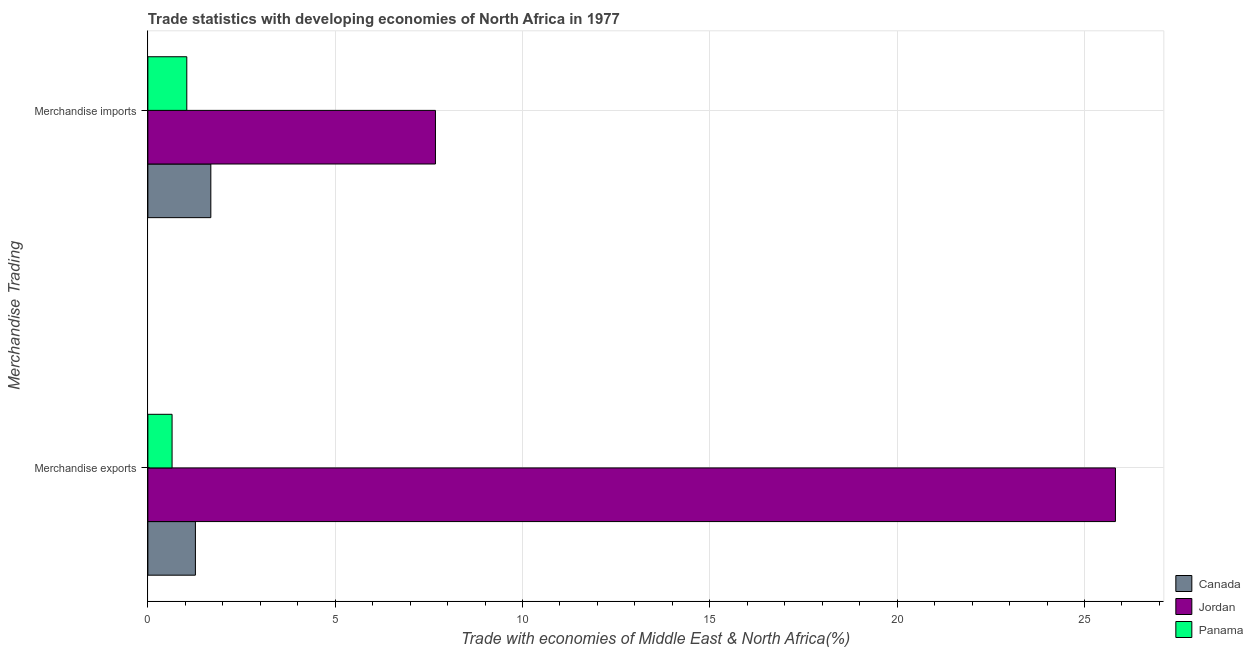How many different coloured bars are there?
Your answer should be compact. 3. How many groups of bars are there?
Provide a short and direct response. 2. How many bars are there on the 2nd tick from the bottom?
Make the answer very short. 3. What is the merchandise imports in Jordan?
Your answer should be very brief. 7.68. Across all countries, what is the maximum merchandise imports?
Provide a short and direct response. 7.68. Across all countries, what is the minimum merchandise exports?
Make the answer very short. 0.65. In which country was the merchandise imports maximum?
Your answer should be very brief. Jordan. In which country was the merchandise exports minimum?
Your answer should be compact. Panama. What is the total merchandise exports in the graph?
Provide a short and direct response. 27.74. What is the difference between the merchandise exports in Jordan and that in Canada?
Your response must be concise. 24.56. What is the difference between the merchandise imports in Canada and the merchandise exports in Panama?
Keep it short and to the point. 1.03. What is the average merchandise exports per country?
Your response must be concise. 9.25. What is the difference between the merchandise exports and merchandise imports in Jordan?
Offer a very short reply. 18.15. What is the ratio of the merchandise exports in Canada to that in Jordan?
Ensure brevity in your answer.  0.05. Is the merchandise exports in Panama less than that in Jordan?
Offer a terse response. Yes. What does the 1st bar from the top in Merchandise imports represents?
Provide a short and direct response. Panama. What does the 3rd bar from the bottom in Merchandise exports represents?
Make the answer very short. Panama. How many countries are there in the graph?
Ensure brevity in your answer.  3. What is the difference between two consecutive major ticks on the X-axis?
Provide a succinct answer. 5. Are the values on the major ticks of X-axis written in scientific E-notation?
Give a very brief answer. No. How many legend labels are there?
Your answer should be compact. 3. How are the legend labels stacked?
Offer a very short reply. Vertical. What is the title of the graph?
Offer a terse response. Trade statistics with developing economies of North Africa in 1977. What is the label or title of the X-axis?
Your response must be concise. Trade with economies of Middle East & North Africa(%). What is the label or title of the Y-axis?
Make the answer very short. Merchandise Trading. What is the Trade with economies of Middle East & North Africa(%) in Canada in Merchandise exports?
Keep it short and to the point. 1.27. What is the Trade with economies of Middle East & North Africa(%) of Jordan in Merchandise exports?
Your answer should be compact. 25.83. What is the Trade with economies of Middle East & North Africa(%) in Panama in Merchandise exports?
Make the answer very short. 0.65. What is the Trade with economies of Middle East & North Africa(%) of Canada in Merchandise imports?
Offer a terse response. 1.68. What is the Trade with economies of Middle East & North Africa(%) in Jordan in Merchandise imports?
Offer a terse response. 7.68. What is the Trade with economies of Middle East & North Africa(%) of Panama in Merchandise imports?
Offer a terse response. 1.04. Across all Merchandise Trading, what is the maximum Trade with economies of Middle East & North Africa(%) of Canada?
Your answer should be very brief. 1.68. Across all Merchandise Trading, what is the maximum Trade with economies of Middle East & North Africa(%) in Jordan?
Make the answer very short. 25.83. Across all Merchandise Trading, what is the maximum Trade with economies of Middle East & North Africa(%) in Panama?
Your answer should be compact. 1.04. Across all Merchandise Trading, what is the minimum Trade with economies of Middle East & North Africa(%) of Canada?
Ensure brevity in your answer.  1.27. Across all Merchandise Trading, what is the minimum Trade with economies of Middle East & North Africa(%) of Jordan?
Provide a succinct answer. 7.68. Across all Merchandise Trading, what is the minimum Trade with economies of Middle East & North Africa(%) in Panama?
Provide a short and direct response. 0.65. What is the total Trade with economies of Middle East & North Africa(%) of Canada in the graph?
Your answer should be very brief. 2.95. What is the total Trade with economies of Middle East & North Africa(%) in Jordan in the graph?
Give a very brief answer. 33.5. What is the total Trade with economies of Middle East & North Africa(%) in Panama in the graph?
Offer a very short reply. 1.69. What is the difference between the Trade with economies of Middle East & North Africa(%) in Canada in Merchandise exports and that in Merchandise imports?
Provide a succinct answer. -0.41. What is the difference between the Trade with economies of Middle East & North Africa(%) of Jordan in Merchandise exports and that in Merchandise imports?
Your answer should be compact. 18.15. What is the difference between the Trade with economies of Middle East & North Africa(%) in Panama in Merchandise exports and that in Merchandise imports?
Give a very brief answer. -0.39. What is the difference between the Trade with economies of Middle East & North Africa(%) of Canada in Merchandise exports and the Trade with economies of Middle East & North Africa(%) of Jordan in Merchandise imports?
Your response must be concise. -6.41. What is the difference between the Trade with economies of Middle East & North Africa(%) of Canada in Merchandise exports and the Trade with economies of Middle East & North Africa(%) of Panama in Merchandise imports?
Ensure brevity in your answer.  0.23. What is the difference between the Trade with economies of Middle East & North Africa(%) of Jordan in Merchandise exports and the Trade with economies of Middle East & North Africa(%) of Panama in Merchandise imports?
Your answer should be compact. 24.79. What is the average Trade with economies of Middle East & North Africa(%) in Canada per Merchandise Trading?
Your response must be concise. 1.47. What is the average Trade with economies of Middle East & North Africa(%) of Jordan per Merchandise Trading?
Offer a very short reply. 16.75. What is the average Trade with economies of Middle East & North Africa(%) of Panama per Merchandise Trading?
Your response must be concise. 0.84. What is the difference between the Trade with economies of Middle East & North Africa(%) in Canada and Trade with economies of Middle East & North Africa(%) in Jordan in Merchandise exports?
Your answer should be compact. -24.56. What is the difference between the Trade with economies of Middle East & North Africa(%) of Canada and Trade with economies of Middle East & North Africa(%) of Panama in Merchandise exports?
Give a very brief answer. 0.62. What is the difference between the Trade with economies of Middle East & North Africa(%) of Jordan and Trade with economies of Middle East & North Africa(%) of Panama in Merchandise exports?
Provide a short and direct response. 25.18. What is the difference between the Trade with economies of Middle East & North Africa(%) of Canada and Trade with economies of Middle East & North Africa(%) of Jordan in Merchandise imports?
Your answer should be compact. -6. What is the difference between the Trade with economies of Middle East & North Africa(%) of Canada and Trade with economies of Middle East & North Africa(%) of Panama in Merchandise imports?
Provide a short and direct response. 0.64. What is the difference between the Trade with economies of Middle East & North Africa(%) of Jordan and Trade with economies of Middle East & North Africa(%) of Panama in Merchandise imports?
Provide a succinct answer. 6.64. What is the ratio of the Trade with economies of Middle East & North Africa(%) in Canada in Merchandise exports to that in Merchandise imports?
Offer a terse response. 0.76. What is the ratio of the Trade with economies of Middle East & North Africa(%) of Jordan in Merchandise exports to that in Merchandise imports?
Offer a very short reply. 3.36. What is the ratio of the Trade with economies of Middle East & North Africa(%) of Panama in Merchandise exports to that in Merchandise imports?
Give a very brief answer. 0.62. What is the difference between the highest and the second highest Trade with economies of Middle East & North Africa(%) in Canada?
Your answer should be very brief. 0.41. What is the difference between the highest and the second highest Trade with economies of Middle East & North Africa(%) in Jordan?
Ensure brevity in your answer.  18.15. What is the difference between the highest and the second highest Trade with economies of Middle East & North Africa(%) of Panama?
Provide a short and direct response. 0.39. What is the difference between the highest and the lowest Trade with economies of Middle East & North Africa(%) of Canada?
Your response must be concise. 0.41. What is the difference between the highest and the lowest Trade with economies of Middle East & North Africa(%) of Jordan?
Give a very brief answer. 18.15. What is the difference between the highest and the lowest Trade with economies of Middle East & North Africa(%) in Panama?
Your response must be concise. 0.39. 